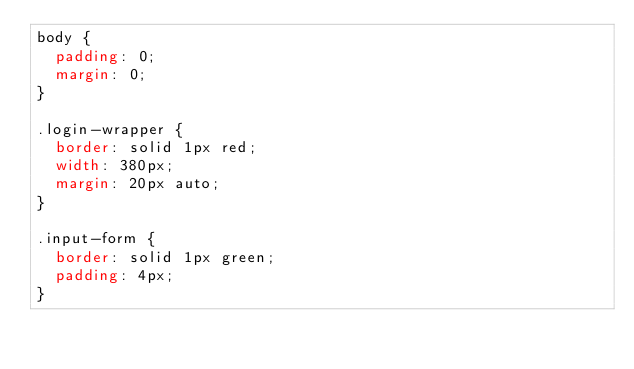Convert code to text. <code><loc_0><loc_0><loc_500><loc_500><_CSS_>body {
  padding: 0;
  margin: 0;
}

.login-wrapper {
  border: solid 1px red;
  width: 380px;
  margin: 20px auto;
}

.input-form {
  border: solid 1px green;
  padding: 4px;
}</code> 